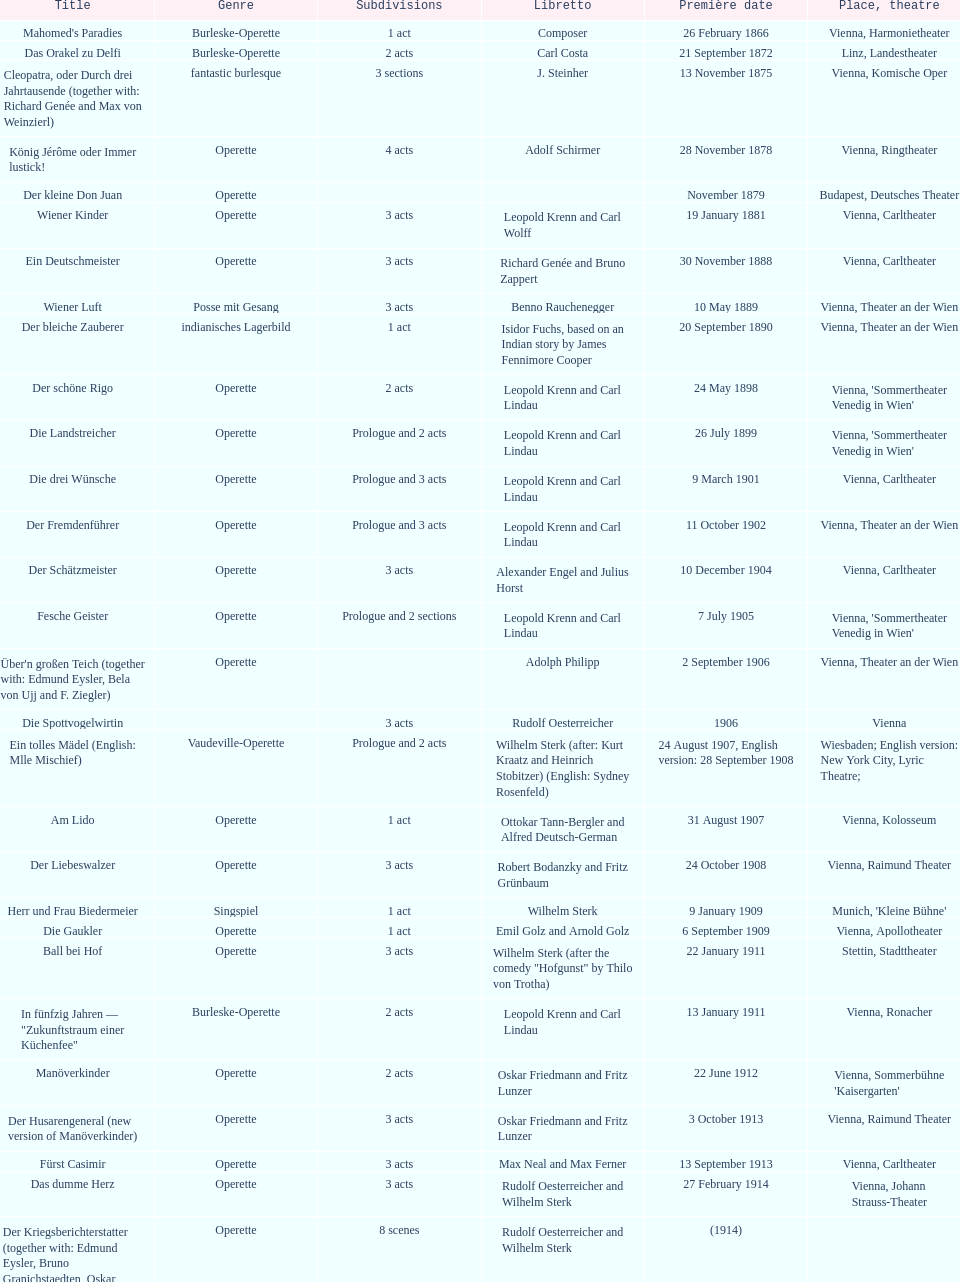Up to which year do all the dates go? 1958. 